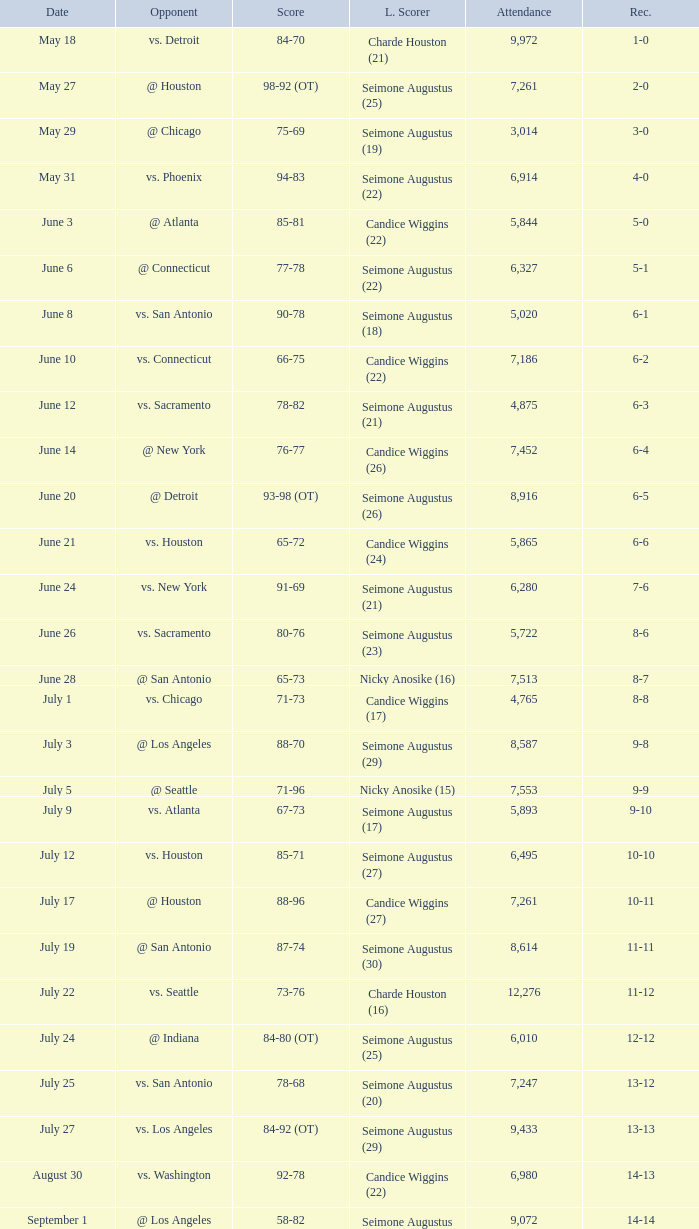Which Score has an Opponent of @ houston, and a Record of 2-0? 98-92 (OT). 